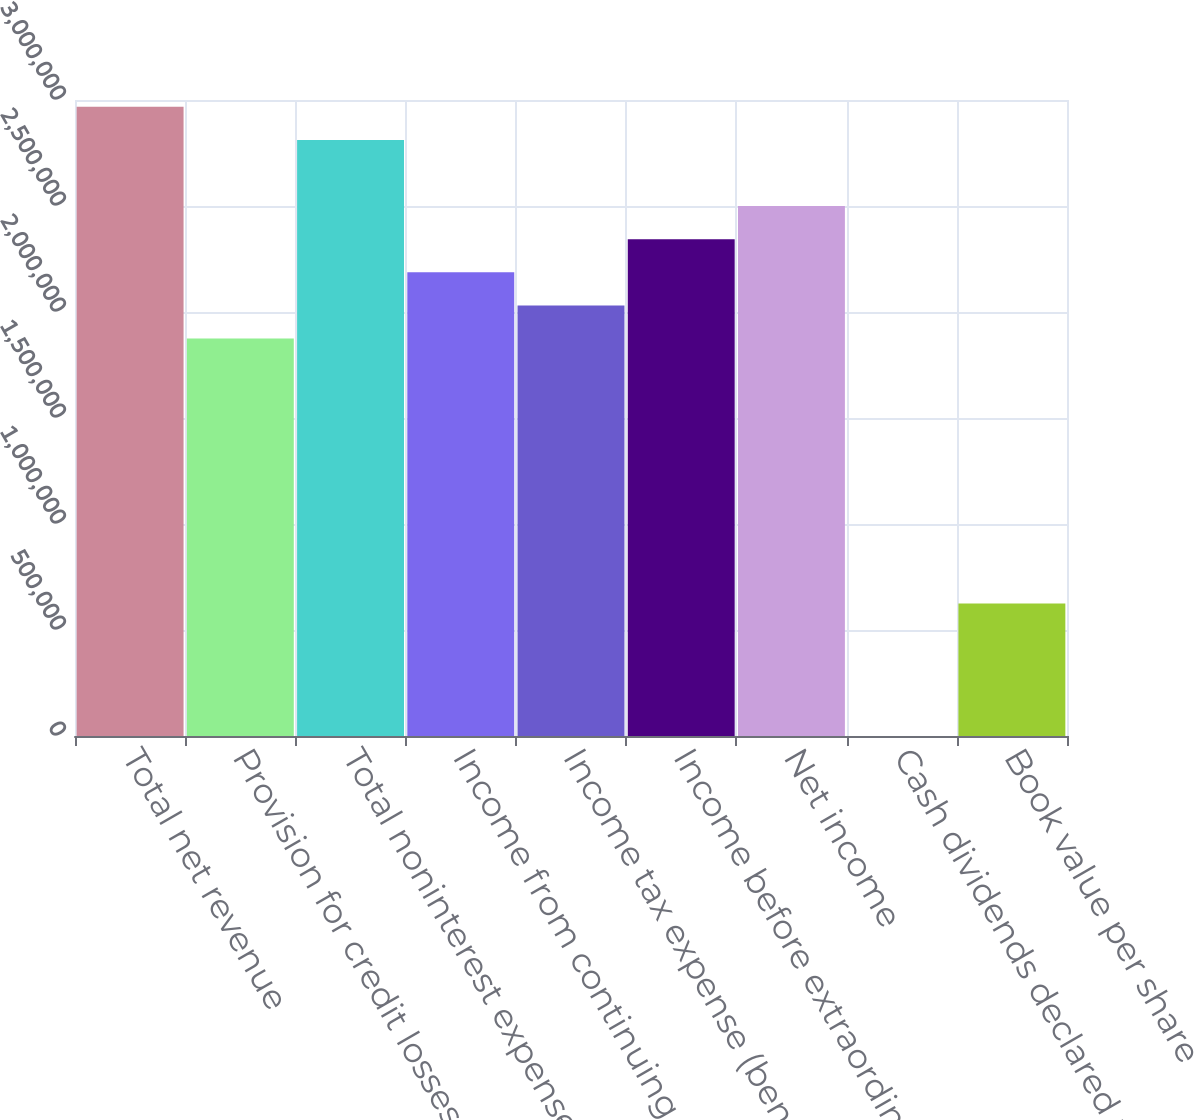<chart> <loc_0><loc_0><loc_500><loc_500><bar_chart><fcel>Total net revenue<fcel>Provision for credit losses<fcel>Total noninterest expense<fcel>Income from continuing<fcel>Income tax expense (benefit)<fcel>Income before extraordinary<fcel>Net income<fcel>Cash dividends declared per<fcel>Book value per share<nl><fcel>2.96808e+06<fcel>1.87458e+06<fcel>2.81186e+06<fcel>2.18701e+06<fcel>2.03079e+06<fcel>2.34322e+06<fcel>2.49943e+06<fcel>1.48<fcel>624860<nl></chart> 